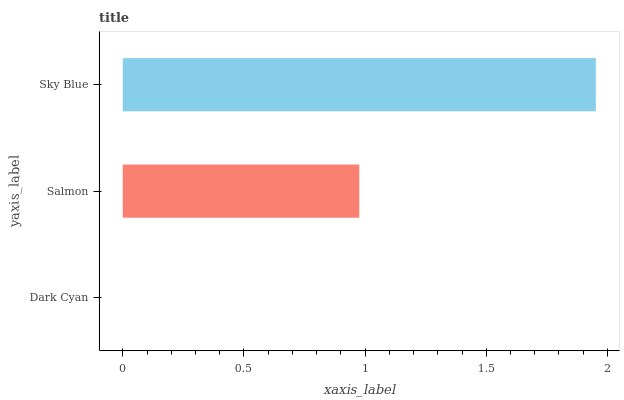Is Dark Cyan the minimum?
Answer yes or no. Yes. Is Sky Blue the maximum?
Answer yes or no. Yes. Is Salmon the minimum?
Answer yes or no. No. Is Salmon the maximum?
Answer yes or no. No. Is Salmon greater than Dark Cyan?
Answer yes or no. Yes. Is Dark Cyan less than Salmon?
Answer yes or no. Yes. Is Dark Cyan greater than Salmon?
Answer yes or no. No. Is Salmon less than Dark Cyan?
Answer yes or no. No. Is Salmon the high median?
Answer yes or no. Yes. Is Salmon the low median?
Answer yes or no. Yes. Is Dark Cyan the high median?
Answer yes or no. No. Is Dark Cyan the low median?
Answer yes or no. No. 